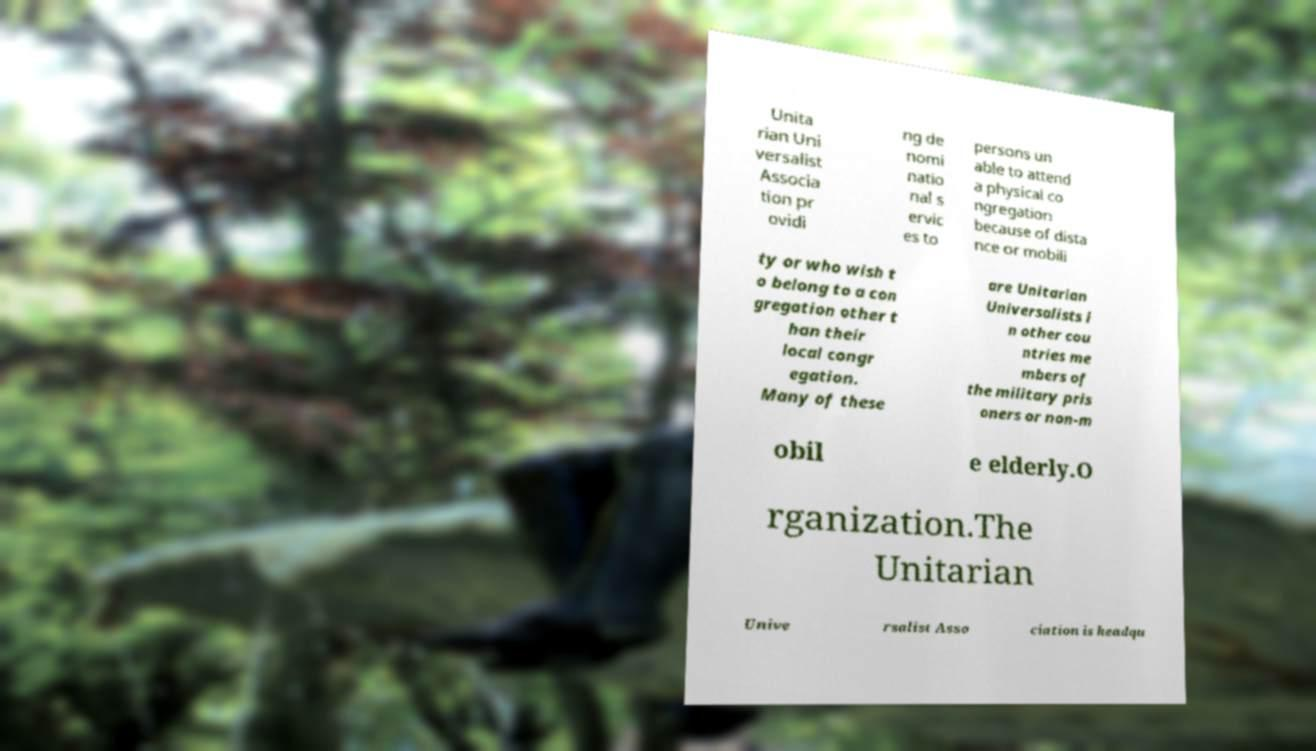Please read and relay the text visible in this image. What does it say? Unita rian Uni versalist Associa tion pr ovidi ng de nomi natio nal s ervic es to persons un able to attend a physical co ngregation because of dista nce or mobili ty or who wish t o belong to a con gregation other t han their local congr egation. Many of these are Unitarian Universalists i n other cou ntries me mbers of the military pris oners or non-m obil e elderly.O rganization.The Unitarian Unive rsalist Asso ciation is headqu 